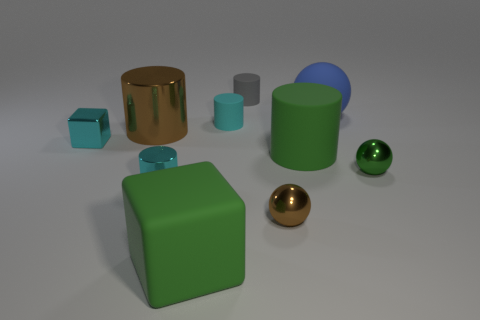Subtract all green cylinders. How many cylinders are left? 4 Subtract all gray cylinders. How many cylinders are left? 4 Subtract all yellow cylinders. Subtract all cyan spheres. How many cylinders are left? 5 Subtract all balls. How many objects are left? 7 Add 5 cyan shiny cubes. How many cyan shiny cubes exist? 6 Subtract 1 green blocks. How many objects are left? 9 Subtract all large brown metal cubes. Subtract all blue matte balls. How many objects are left? 9 Add 2 big brown cylinders. How many big brown cylinders are left? 3 